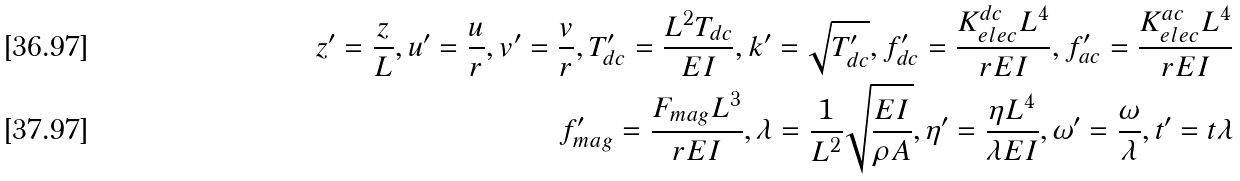Convert formula to latex. <formula><loc_0><loc_0><loc_500><loc_500>z ^ { \prime } = \frac { z } { L } , u ^ { \prime } = \frac { u } { r } , v ^ { \prime } = \frac { v } { r } , T ^ { \prime } _ { d c } = \frac { L ^ { 2 } T _ { d c } } { E I } , k ^ { \prime } = \sqrt { T ^ { \prime } _ { d c } } , f ^ { \prime } _ { d c } = \frac { K _ { e l e c } ^ { d c } L ^ { 4 } } { r E I } , f ^ { \prime } _ { a c } = \frac { K _ { e l e c } ^ { a c } L ^ { 4 } } { r E I } \\ f ^ { \prime } _ { m a g } = \frac { F _ { m a g } L ^ { 3 } } { r E I } , \lambda = \frac { 1 } { L ^ { 2 } } \sqrt { \frac { E I } { \rho A } } , \eta ^ { \prime } = \frac { \eta L ^ { 4 } } { \lambda E I } , \omega ^ { \prime } = \frac { \omega } { \lambda } , t ^ { \prime } = t \lambda</formula> 